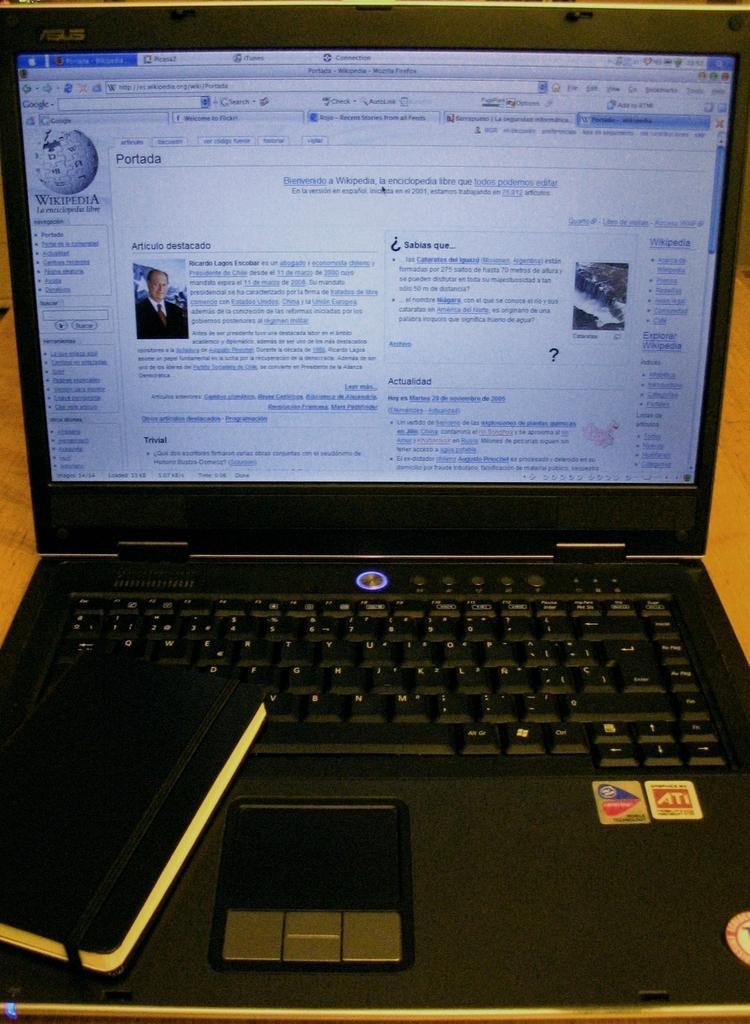Could you give a brief overview of what you see in this image? In this picture I can observe a laptop on the table. The laptop is in black color. I can observe some text on the screen. 